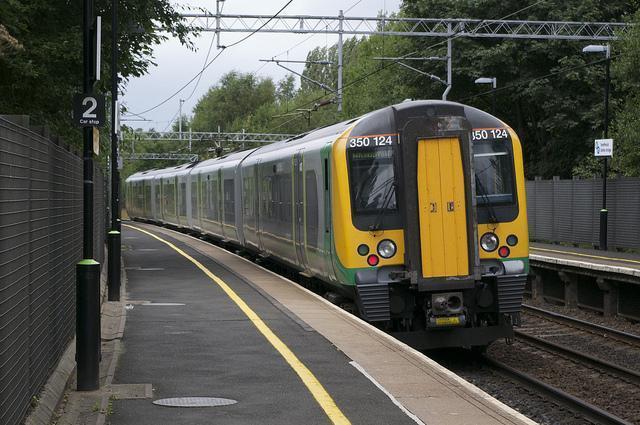How many baby elephants statues on the left of the mother elephants ?
Give a very brief answer. 0. 